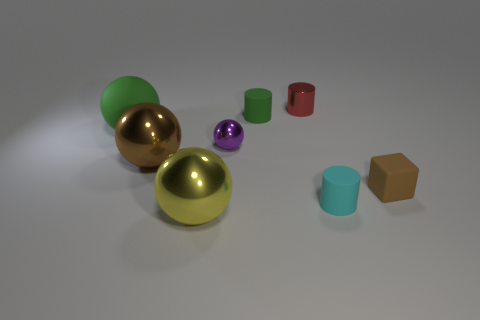Does the tiny metallic cylinder have the same color as the cube?
Offer a very short reply. No. There is a brown matte block; how many large yellow metal objects are behind it?
Provide a succinct answer. 0. What size is the matte object that is both to the right of the matte ball and to the left of the tiny metallic cylinder?
Keep it short and to the point. Small. Are any tiny red objects visible?
Make the answer very short. Yes. What number of other things are the same size as the cyan thing?
Make the answer very short. 4. There is a tiny rubber cylinder that is to the right of the red cylinder; is its color the same as the tiny shiny thing that is to the right of the small sphere?
Your answer should be compact. No. There is a cyan object that is the same shape as the small red thing; what is its size?
Your answer should be compact. Small. Is the small object behind the small green rubber cylinder made of the same material as the small brown thing in front of the tiny purple sphere?
Your answer should be very brief. No. How many metal things are red things or small purple spheres?
Your answer should be compact. 2. The green thing on the left side of the purple thing that is to the left of the brown object that is to the right of the red cylinder is made of what material?
Offer a terse response. Rubber. 